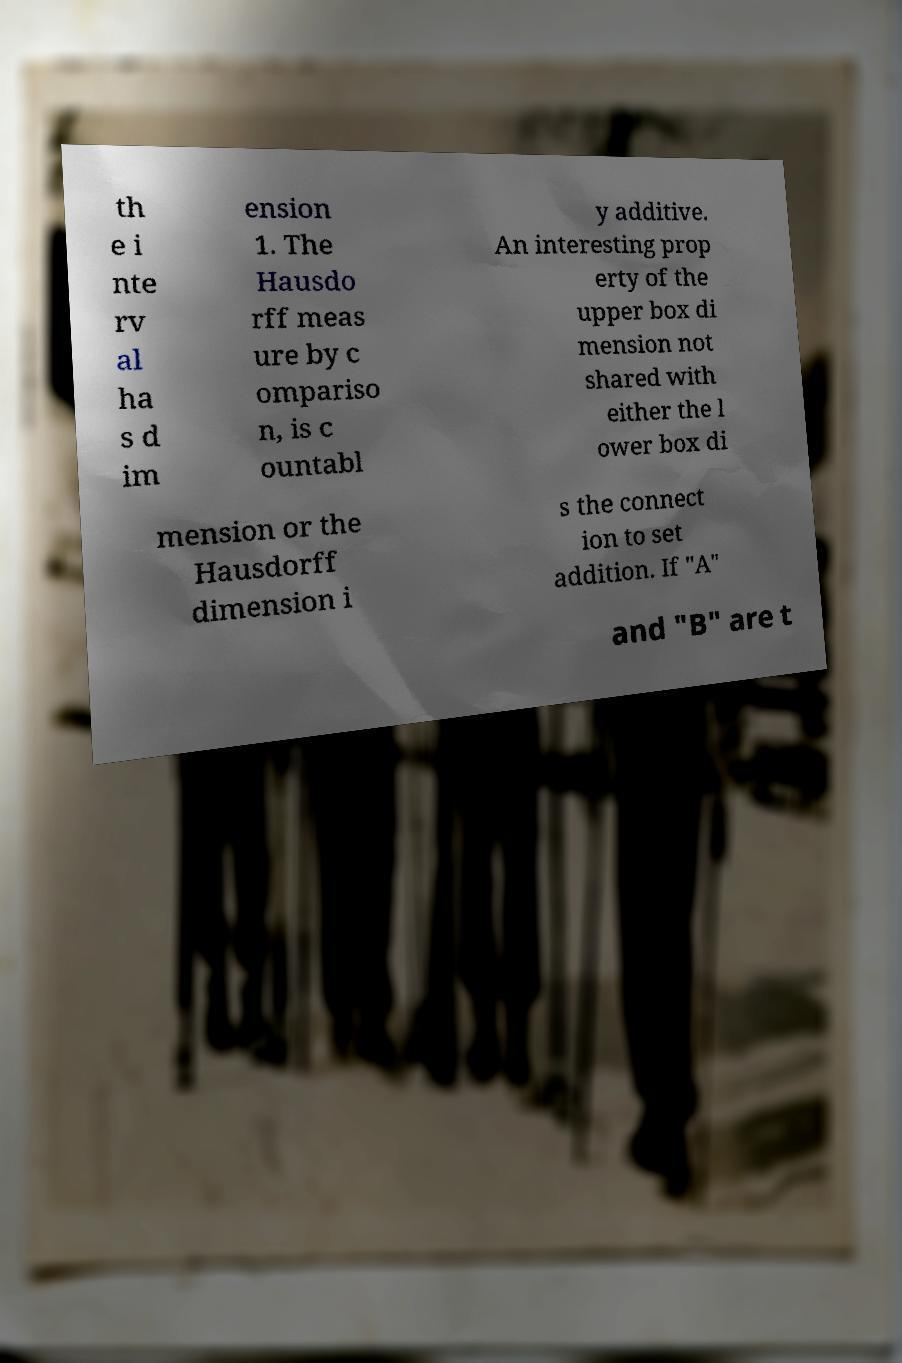Can you accurately transcribe the text from the provided image for me? th e i nte rv al ha s d im ension 1. The Hausdo rff meas ure by c ompariso n, is c ountabl y additive. An interesting prop erty of the upper box di mension not shared with either the l ower box di mension or the Hausdorff dimension i s the connect ion to set addition. If "A" and "B" are t 